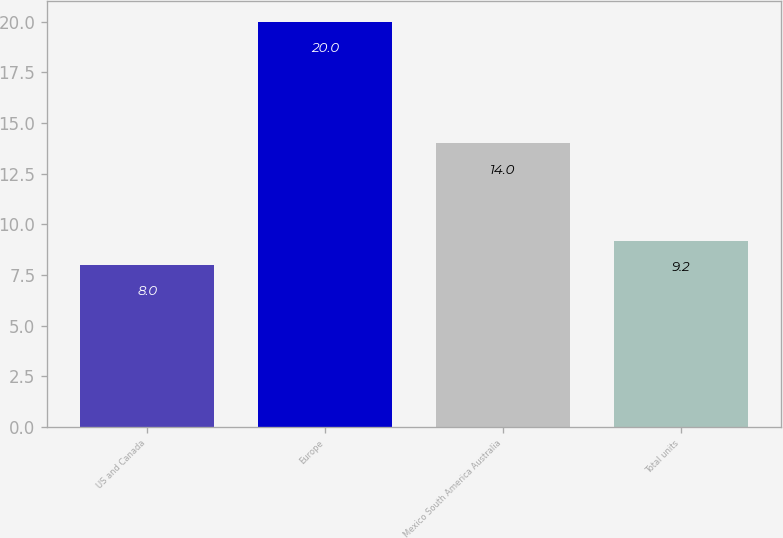Convert chart. <chart><loc_0><loc_0><loc_500><loc_500><bar_chart><fcel>US and Canada<fcel>Europe<fcel>Mexico South America Australia<fcel>Total units<nl><fcel>8<fcel>20<fcel>14<fcel>9.2<nl></chart> 